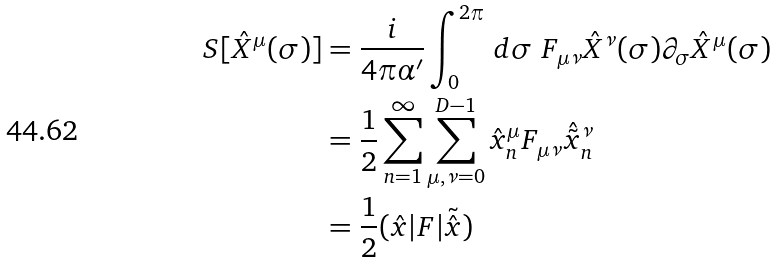Convert formula to latex. <formula><loc_0><loc_0><loc_500><loc_500>S [ \hat { X } ^ { \mu } ( \sigma ) ] & = \frac { i } { 4 \pi \alpha ^ { \prime } } \int _ { 0 } ^ { 2 \pi } \, d \sigma \ F _ { \mu \nu } \hat { X } ^ { \nu } ( \sigma ) \partial _ { \sigma } \hat { X } ^ { \mu } ( \sigma ) \\ & = \frac { 1 } { 2 } \sum _ { n = 1 } ^ { \infty } \sum _ { \mu , \nu = 0 } ^ { D - 1 } \hat { x } _ { n } ^ { \mu } F _ { \mu \nu } \hat { \tilde { x } } _ { n } ^ { \nu } \\ & = \frac { 1 } { 2 } ( \hat { x } | F | \tilde { \hat { x } } )</formula> 